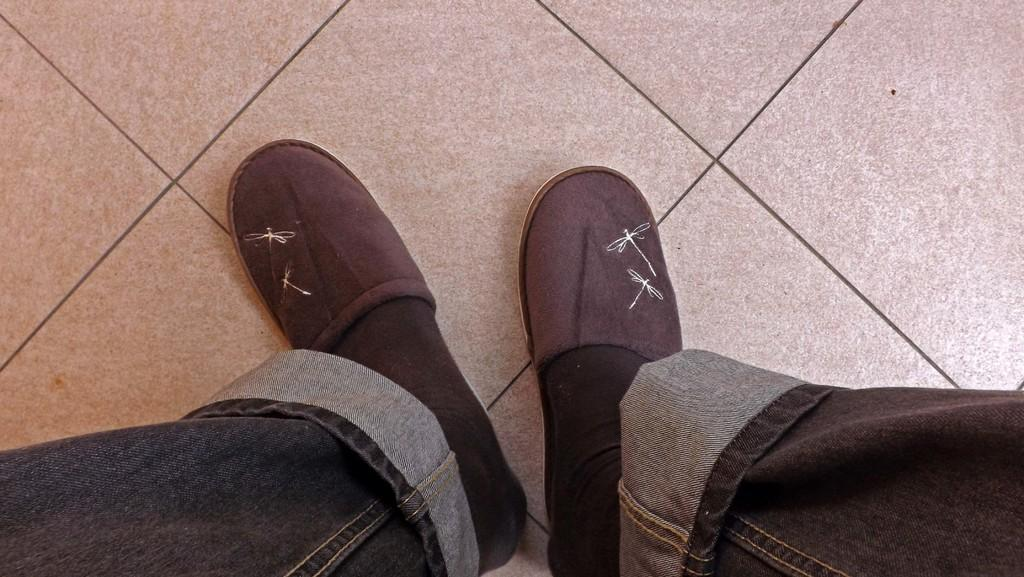Who or what is present in the image? There is a person in the image. What part of the person's body can be seen? The person's legs are visible. What type of clothing is the person wearing on their legs? The person's legs are wearing jeans, socks, and footwear. What surface is beneath the person's legs? There is a floor in the image. How many kittens are playing in the person's pocket in the image? There are no kittens present in the image, and the person's pocket is not visible. 